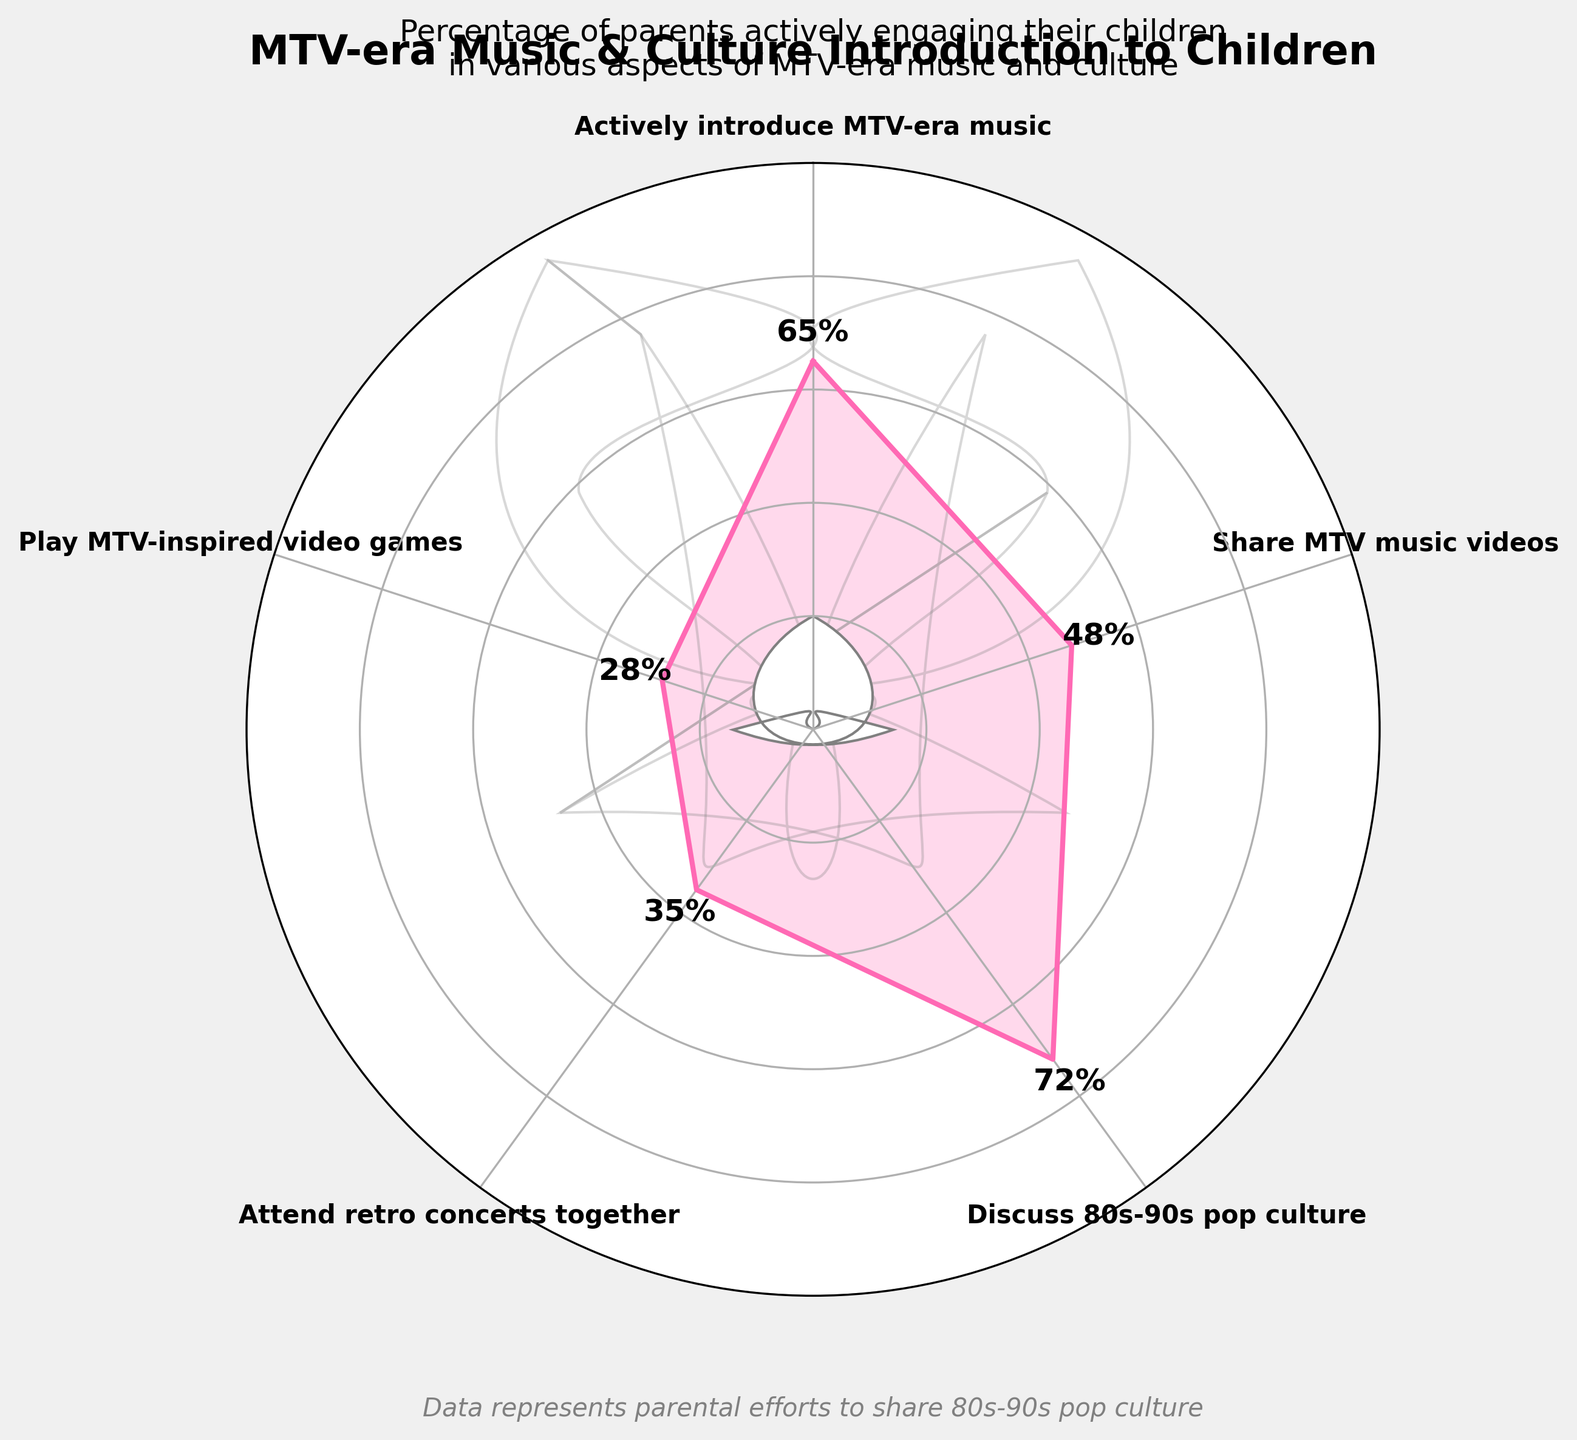what percentage of parents actively introduce their children to MTV-era music? The gauge chart shows a value corresponding to parents actively introducing their children to MTV-era music. Locate the section labeled "Actively introduce MTV-era music" and find the corresponding percentage value.
Answer: 65% which activity has the highest percentage of parental involvement? To find the activity with the highest percentage, compare all labeled sections and identify the one with the highest value. The section "Discuss 80s-90s pop culture" shows the highest percentage.
Answer: Discuss 80s-90s pop culture how much greater is the percentage of parents who discuss 80s-90s pop culture compared to those who play MTV-inspired video games with their children? Identify the percentages for both activities from the chart: discussing 80s-90s pop culture (72%) and playing MTV-inspired video games (28%). Subtract the smaller value from the larger value: 72% - 28% = 44%.
Answer: 44% do more parents share MTV music videos or attend retro concerts with their children? Compare the percentages of parents who share MTV music videos (48%) with those who attend retro concerts (35%). The higher percentage indicates more parental involvement.
Answer: share MTV music videos What is the average percentage of parents participating in all activities shown in the chart? Sum all the percentages: 65 + 48 + 72 + 35 + 28 = 248. Divide by the number of activities (5) to find the average: 248 / 5 = 49.6.
Answer: 49.6% how many activities have more than 50% parental involvement? Identify the activities with percentages greater than 50%: Actively introduce MTV-era music (65%) and Discuss 80s-90s pop culture (72%). Count these activities.
Answer: 2 Which activities fall under the 30% parental involvement threshold in the chart? Look for the activities with percentages less than 30%: The only activity is playing MTV-inspired video games (28%).
Answer: play MTV-inspired video games What percentage of parents share MTV music videos with their children? Locate the section labeled "Share MTV music videos" and extract the corresponding percentage value from the chart.
Answer: 48% What is the range of parental involvement percentages across all activities shown? Determine the maximum and minimum percentages, which are 72% (Discuss 80s-90s pop culture) and 28% (Play MTV-inspired video games). Subtract the minimum from the maximum: 72% - 28% = 44%.
Answer: 44% 